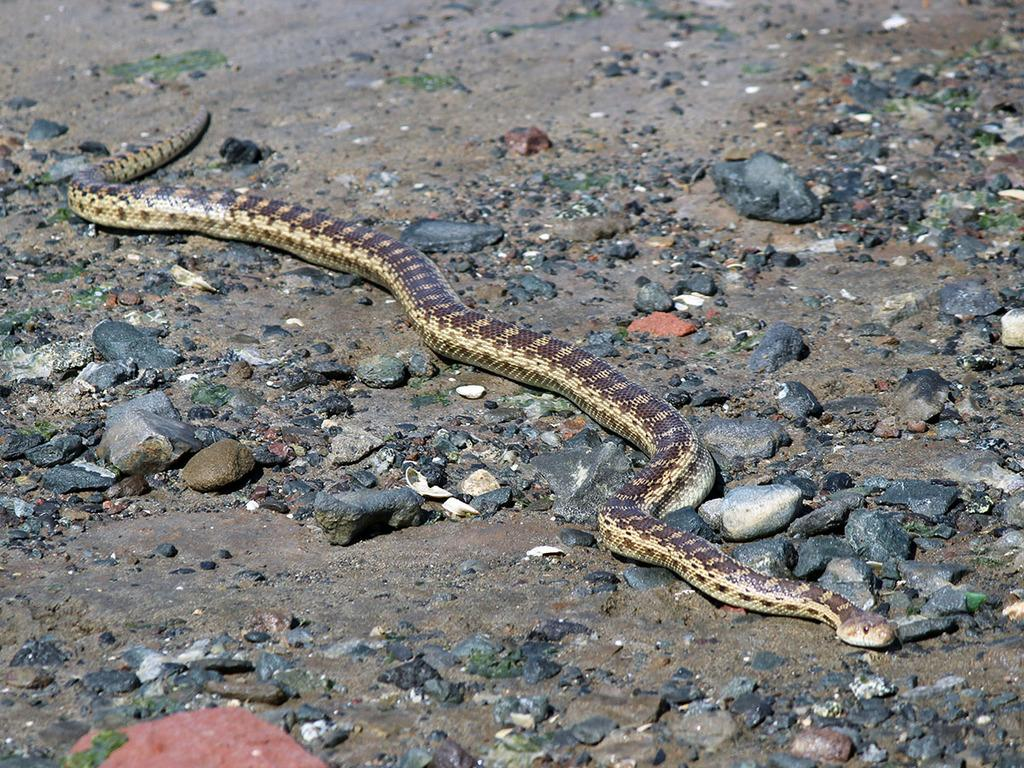What type of surface can be seen in the image? There is ground visible in the image. What is present on the ground? There are stones on the ground. What type of animal is in the image? There is a snake in the image. What colors does the snake have? The snake is cream and brown in color. What flavor of grass can be seen in the image? There is no grass present in the image, so it is not possible to determine the flavor of any grass. 